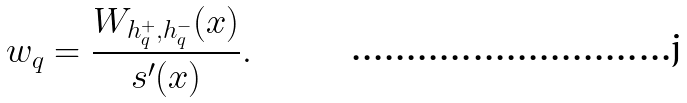Convert formula to latex. <formula><loc_0><loc_0><loc_500><loc_500>w _ { q } = \frac { W _ { h ^ { + } _ { q } , h ^ { - } _ { q } } ( x ) } { s ^ { \prime } ( x ) } .</formula> 